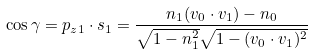Convert formula to latex. <formula><loc_0><loc_0><loc_500><loc_500>\cos \gamma = { p } _ { z 1 } \cdot { s } _ { 1 } = \frac { n _ { 1 } ( { v } _ { 0 } \cdot { v } _ { 1 } ) - n _ { 0 } } { \sqrt { 1 - n _ { 1 } ^ { 2 } } \sqrt { 1 - ( { v } _ { 0 } \cdot { v } _ { 1 } ) ^ { 2 } } }</formula> 